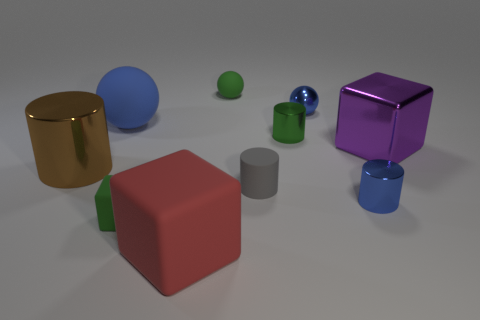Subtract all tiny rubber cylinders. How many cylinders are left? 3 Subtract all blue cylinders. How many cylinders are left? 3 Subtract all balls. How many objects are left? 7 Subtract 2 blocks. How many blocks are left? 1 Subtract 1 purple cubes. How many objects are left? 9 Subtract all red spheres. Subtract all yellow blocks. How many spheres are left? 3 Subtract all purple balls. How many blue blocks are left? 0 Subtract all small metallic things. Subtract all green balls. How many objects are left? 6 Add 7 small green spheres. How many small green spheres are left? 8 Add 5 large purple metal objects. How many large purple metal objects exist? 6 